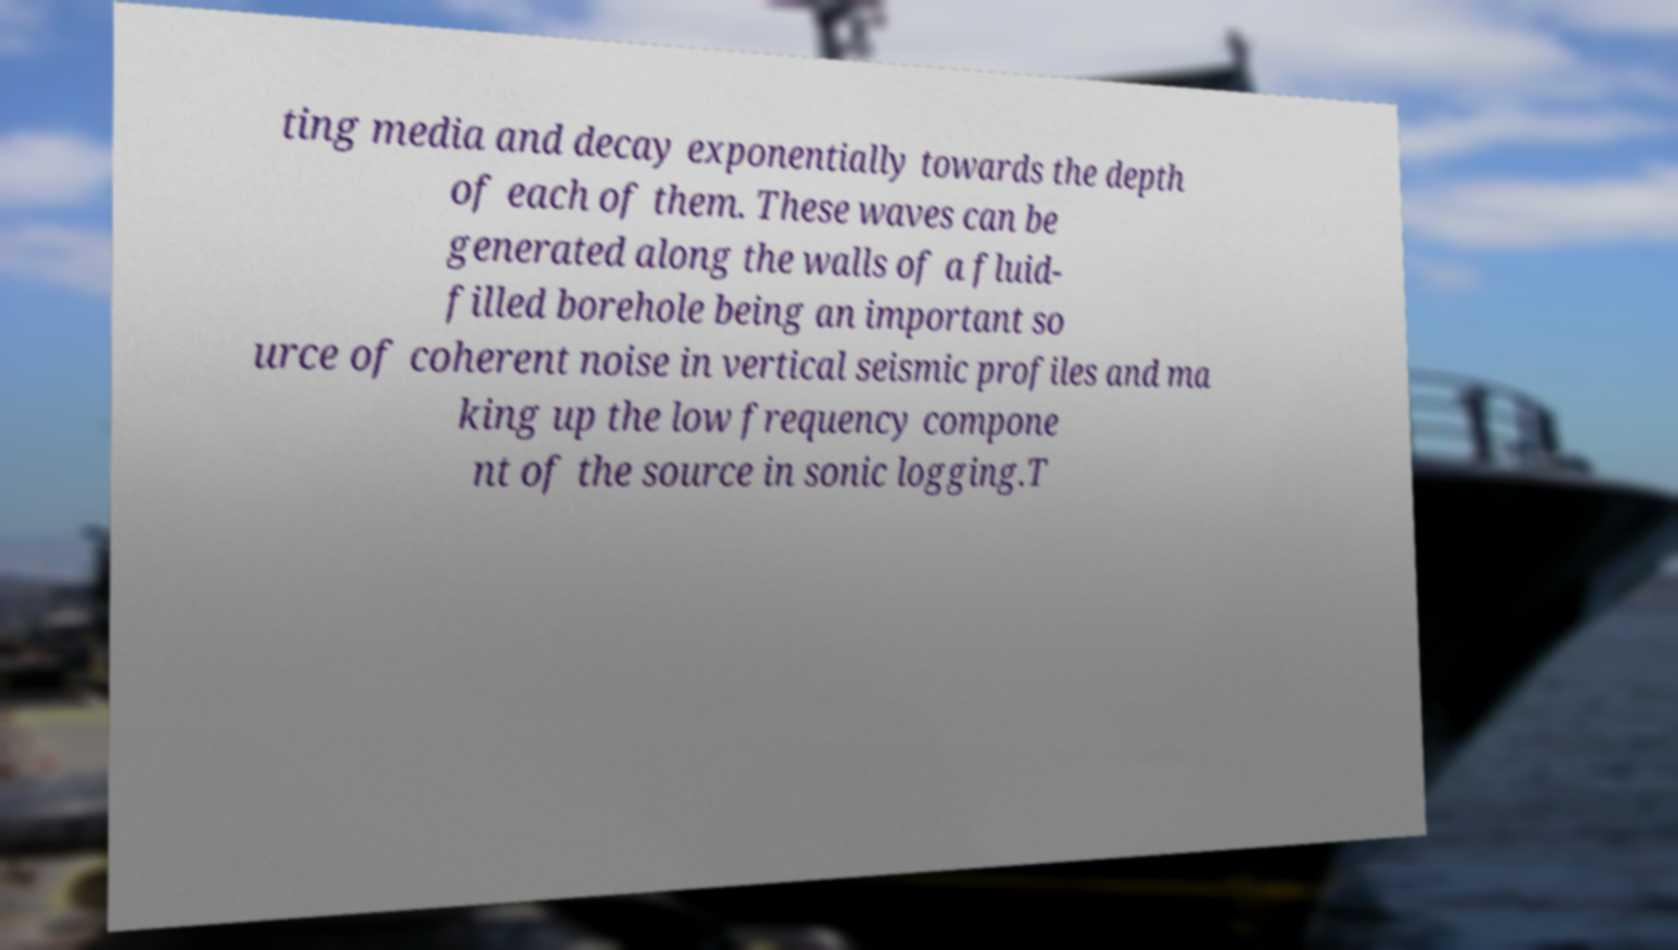Please read and relay the text visible in this image. What does it say? ting media and decay exponentially towards the depth of each of them. These waves can be generated along the walls of a fluid- filled borehole being an important so urce of coherent noise in vertical seismic profiles and ma king up the low frequency compone nt of the source in sonic logging.T 